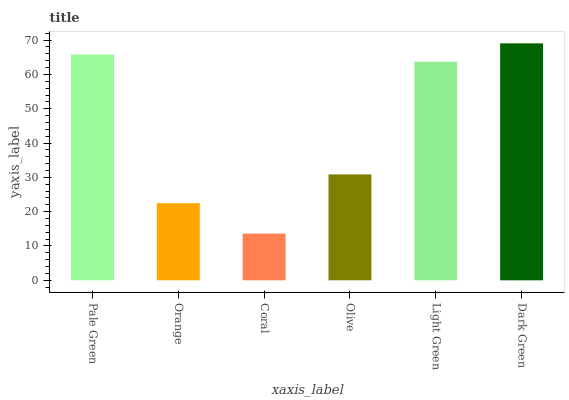Is Coral the minimum?
Answer yes or no. Yes. Is Dark Green the maximum?
Answer yes or no. Yes. Is Orange the minimum?
Answer yes or no. No. Is Orange the maximum?
Answer yes or no. No. Is Pale Green greater than Orange?
Answer yes or no. Yes. Is Orange less than Pale Green?
Answer yes or no. Yes. Is Orange greater than Pale Green?
Answer yes or no. No. Is Pale Green less than Orange?
Answer yes or no. No. Is Light Green the high median?
Answer yes or no. Yes. Is Olive the low median?
Answer yes or no. Yes. Is Coral the high median?
Answer yes or no. No. Is Coral the low median?
Answer yes or no. No. 